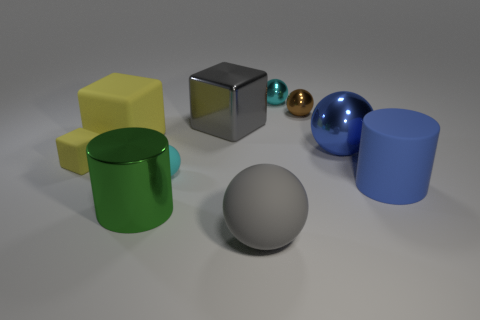What number of objects are either cyan matte cubes or large matte things that are on the right side of the green cylinder?
Your answer should be compact. 2. How many other objects are the same shape as the tiny brown object?
Keep it short and to the point. 4. Do the cyan thing that is right of the tiny cyan matte object and the tiny yellow thing have the same material?
Offer a terse response. No. What number of objects are either big brown balls or cubes?
Your response must be concise. 3. The green thing that is the same shape as the big blue rubber thing is what size?
Offer a very short reply. Large. What is the size of the gray matte object?
Give a very brief answer. Large. Are there more small rubber spheres on the left side of the big metallic sphere than small red cylinders?
Your answer should be very brief. Yes. Is there anything else that is the same material as the big green cylinder?
Provide a short and direct response. Yes. Does the big sphere that is in front of the blue rubber cylinder have the same color as the large metallic object in front of the tiny matte sphere?
Your answer should be very brief. No. There is a cyan object on the right side of the large gray sphere that is in front of the blue matte cylinder that is in front of the large gray metallic thing; what is it made of?
Your answer should be very brief. Metal. 